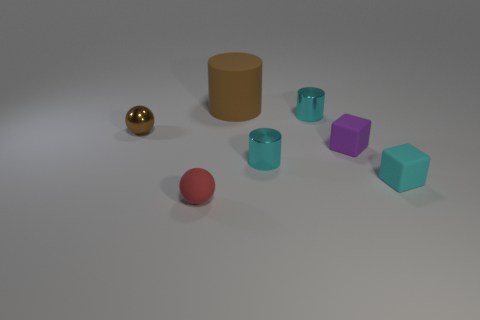Add 1 red balls. How many objects exist? 8 Subtract all balls. How many objects are left? 5 Add 2 small brown spheres. How many small brown spheres are left? 3 Add 5 red shiny cylinders. How many red shiny cylinders exist? 5 Subtract 0 red cylinders. How many objects are left? 7 Subtract all brown shiny balls. Subtract all tiny red matte spheres. How many objects are left? 5 